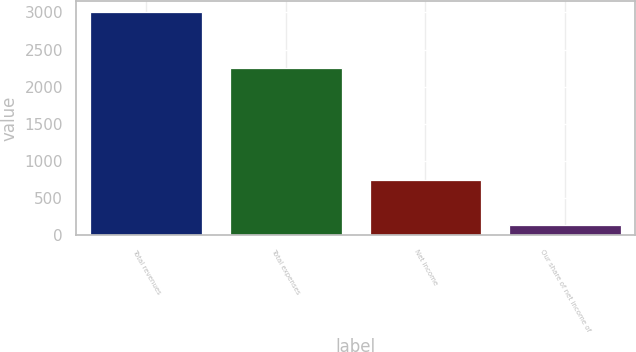Convert chart. <chart><loc_0><loc_0><loc_500><loc_500><bar_chart><fcel>Total revenues<fcel>Total expenses<fcel>Net income<fcel>Our share of net income of<nl><fcel>3002.9<fcel>2253.2<fcel>738.6<fcel>133.4<nl></chart> 